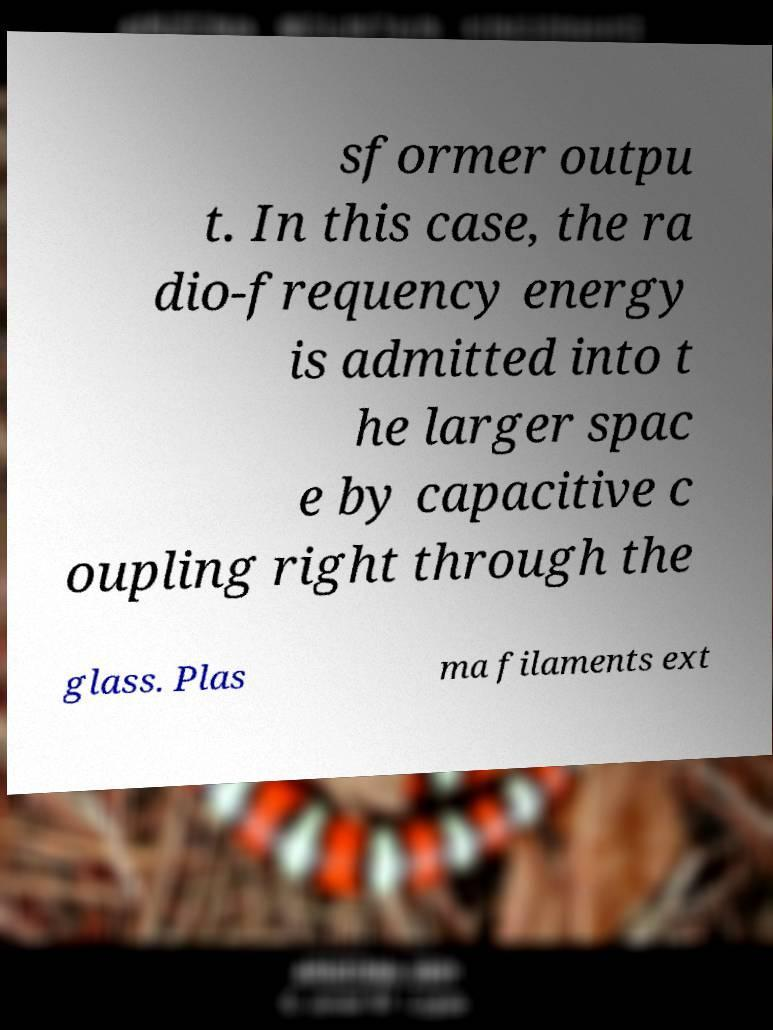Please identify and transcribe the text found in this image. sformer outpu t. In this case, the ra dio-frequency energy is admitted into t he larger spac e by capacitive c oupling right through the glass. Plas ma filaments ext 